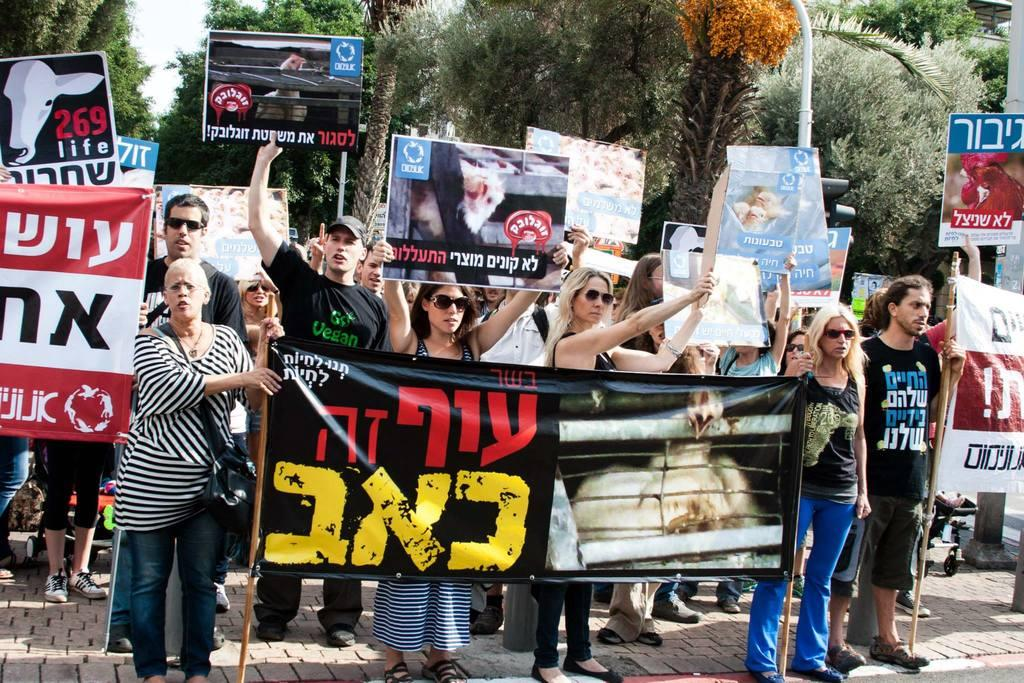What are the people in the image doing? The people in the image are holding banners. What can be seen in the background of the image? There are trees in the background of the image. What is visible at the bottom of the image? There is a floor visible at the bottom of the image. What type of pet can be seen playing chess in the image? There is no pet or chess game present in the image. 